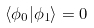<formula> <loc_0><loc_0><loc_500><loc_500>\langle \phi _ { 0 } | \phi _ { 1 } \rangle = 0</formula> 